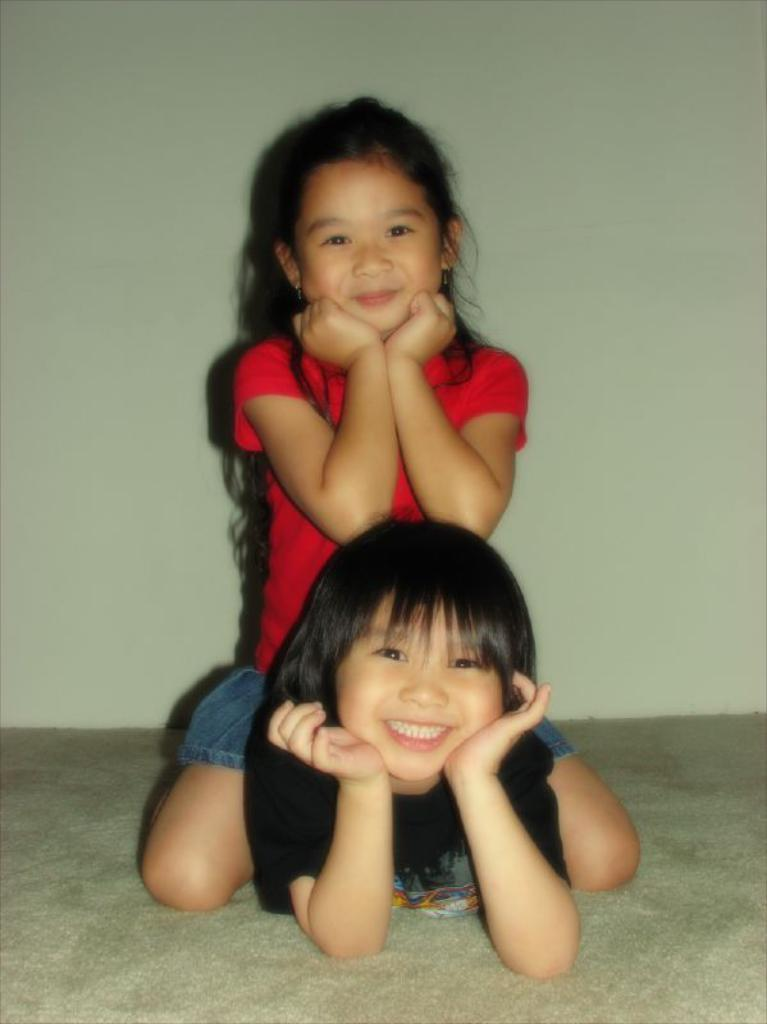What is the child doing in the image? The child is laying on the bed. What is the child wearing in the image? The child is wearing a black color t-shirt. What is the other girl doing in the image? The girl is sitting on the child. What is the girl wearing in the image? The girl is wearing a red color t-shirt. What type of silk material is being used to wash the t-shirts in the image? There is no silk material or washing activity present in the image. 